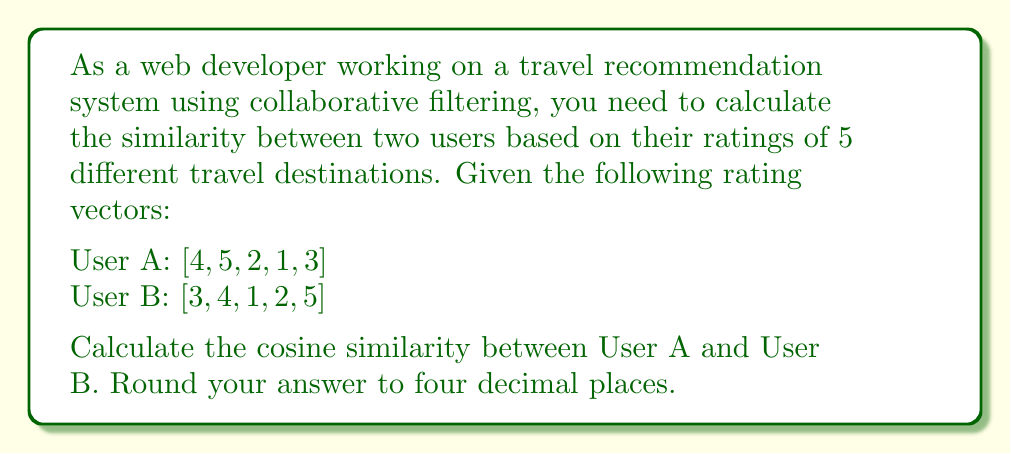Could you help me with this problem? To calculate the cosine similarity between two users in a collaborative filtering system, we use the following steps:

1. The cosine similarity formula is:

   $$\text{Cosine Similarity} = \frac{\sum_{i=1}^n (A_i \times B_i)}{\sqrt{\sum_{i=1}^n A_i^2} \times \sqrt{\sum_{i=1}^n B_i^2}}$$

   Where $A_i$ and $B_i$ are the ratings of User A and User B for the $i$-th item, respectively.

2. Calculate the dot product of the two vectors (numerator):
   $$(4 \times 3) + (5 \times 4) + (2 \times 1) + (1 \times 2) + (3 \times 5) = 12 + 20 + 2 + 2 + 15 = 51$$

3. Calculate the magnitude of User A's vector:
   $$\sqrt{4^2 + 5^2 + 2^2 + 1^2 + 3^2} = \sqrt{16 + 25 + 4 + 1 + 9} = \sqrt{55} = 7.4162$$

4. Calculate the magnitude of User B's vector:
   $$\sqrt{3^2 + 4^2 + 1^2 + 2^2 + 5^2} = \sqrt{9 + 16 + 1 + 4 + 25} = \sqrt{55} = 7.4162$$

5. Apply the cosine similarity formula:
   $$\text{Cosine Similarity} = \frac{51}{7.4162 \times 7.4162} = \frac{51}{55} = 0.9273$$

6. Round the result to four decimal places: 0.9273
Answer: 0.9273 